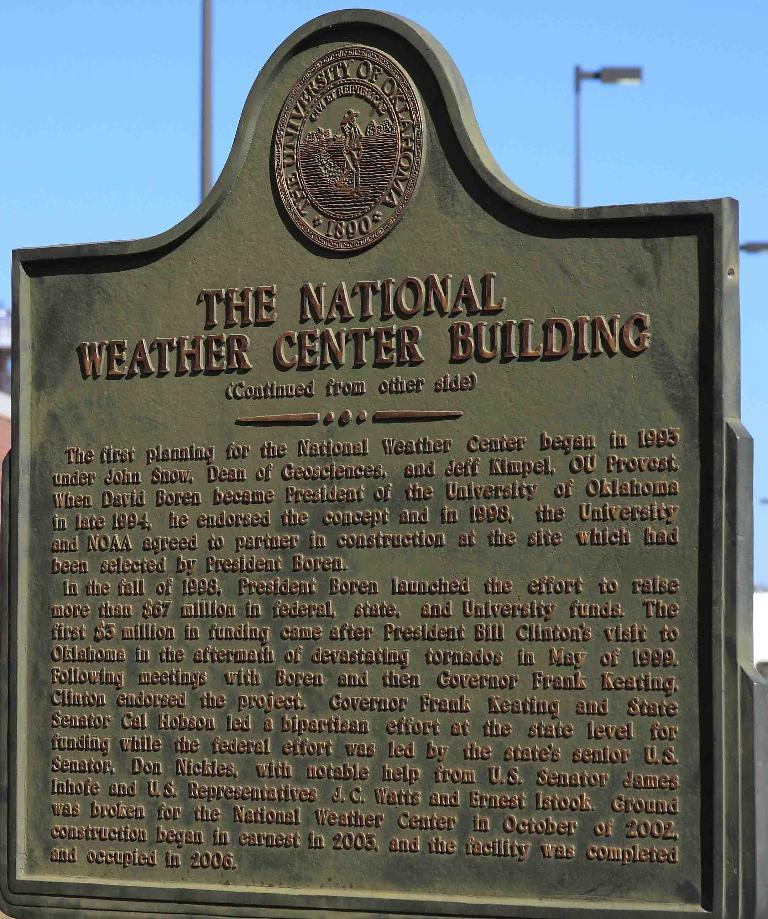<image>
Present a compact description of the photo's key features. the national weather center building sign in green 